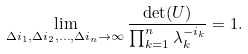Convert formula to latex. <formula><loc_0><loc_0><loc_500><loc_500>\lim _ { \Delta i _ { 1 } , \Delta i _ { 2 } , \dots , \Delta i _ { n } \rightarrow \infty } \frac { \det ( U ) } { \prod _ { k = 1 } ^ { n } \lambda _ { k } ^ { - i _ { k } } } = 1 .</formula> 